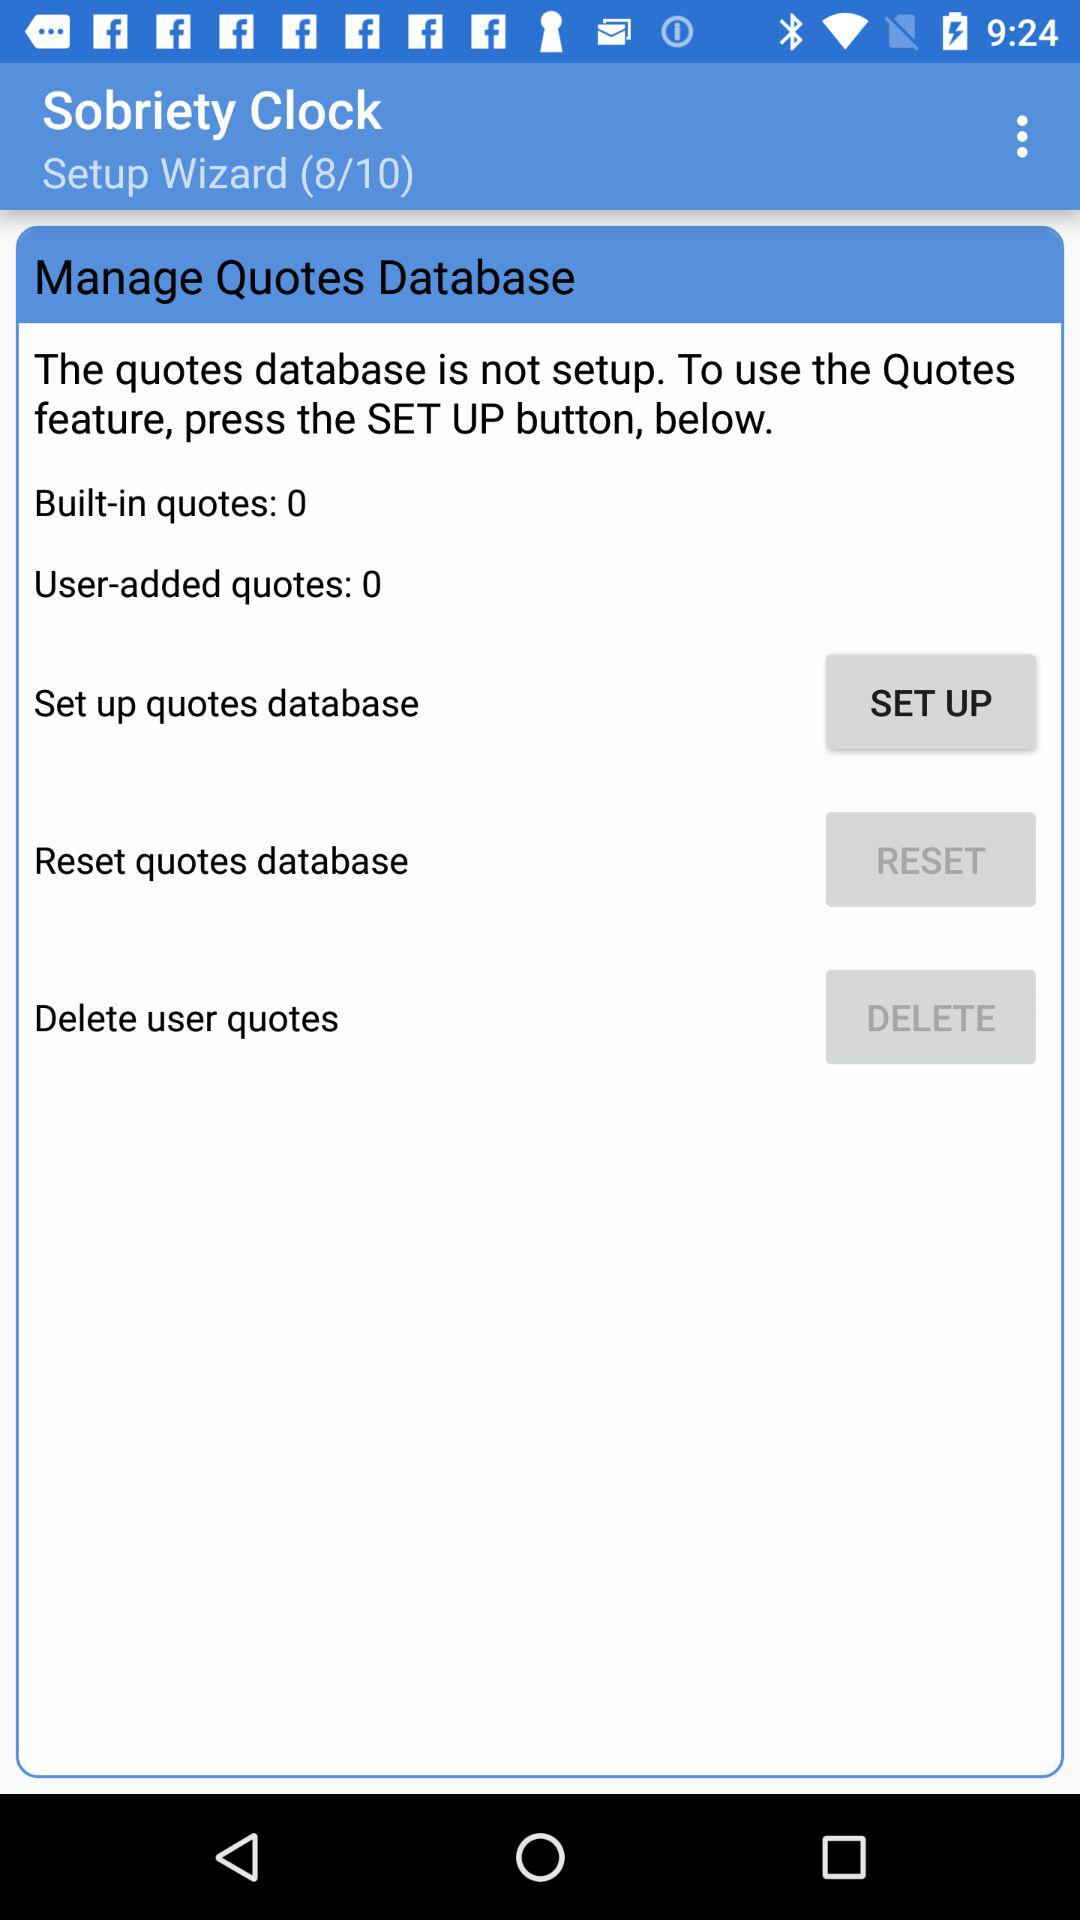What is the app name? The app name is "Sobriety Clock". 